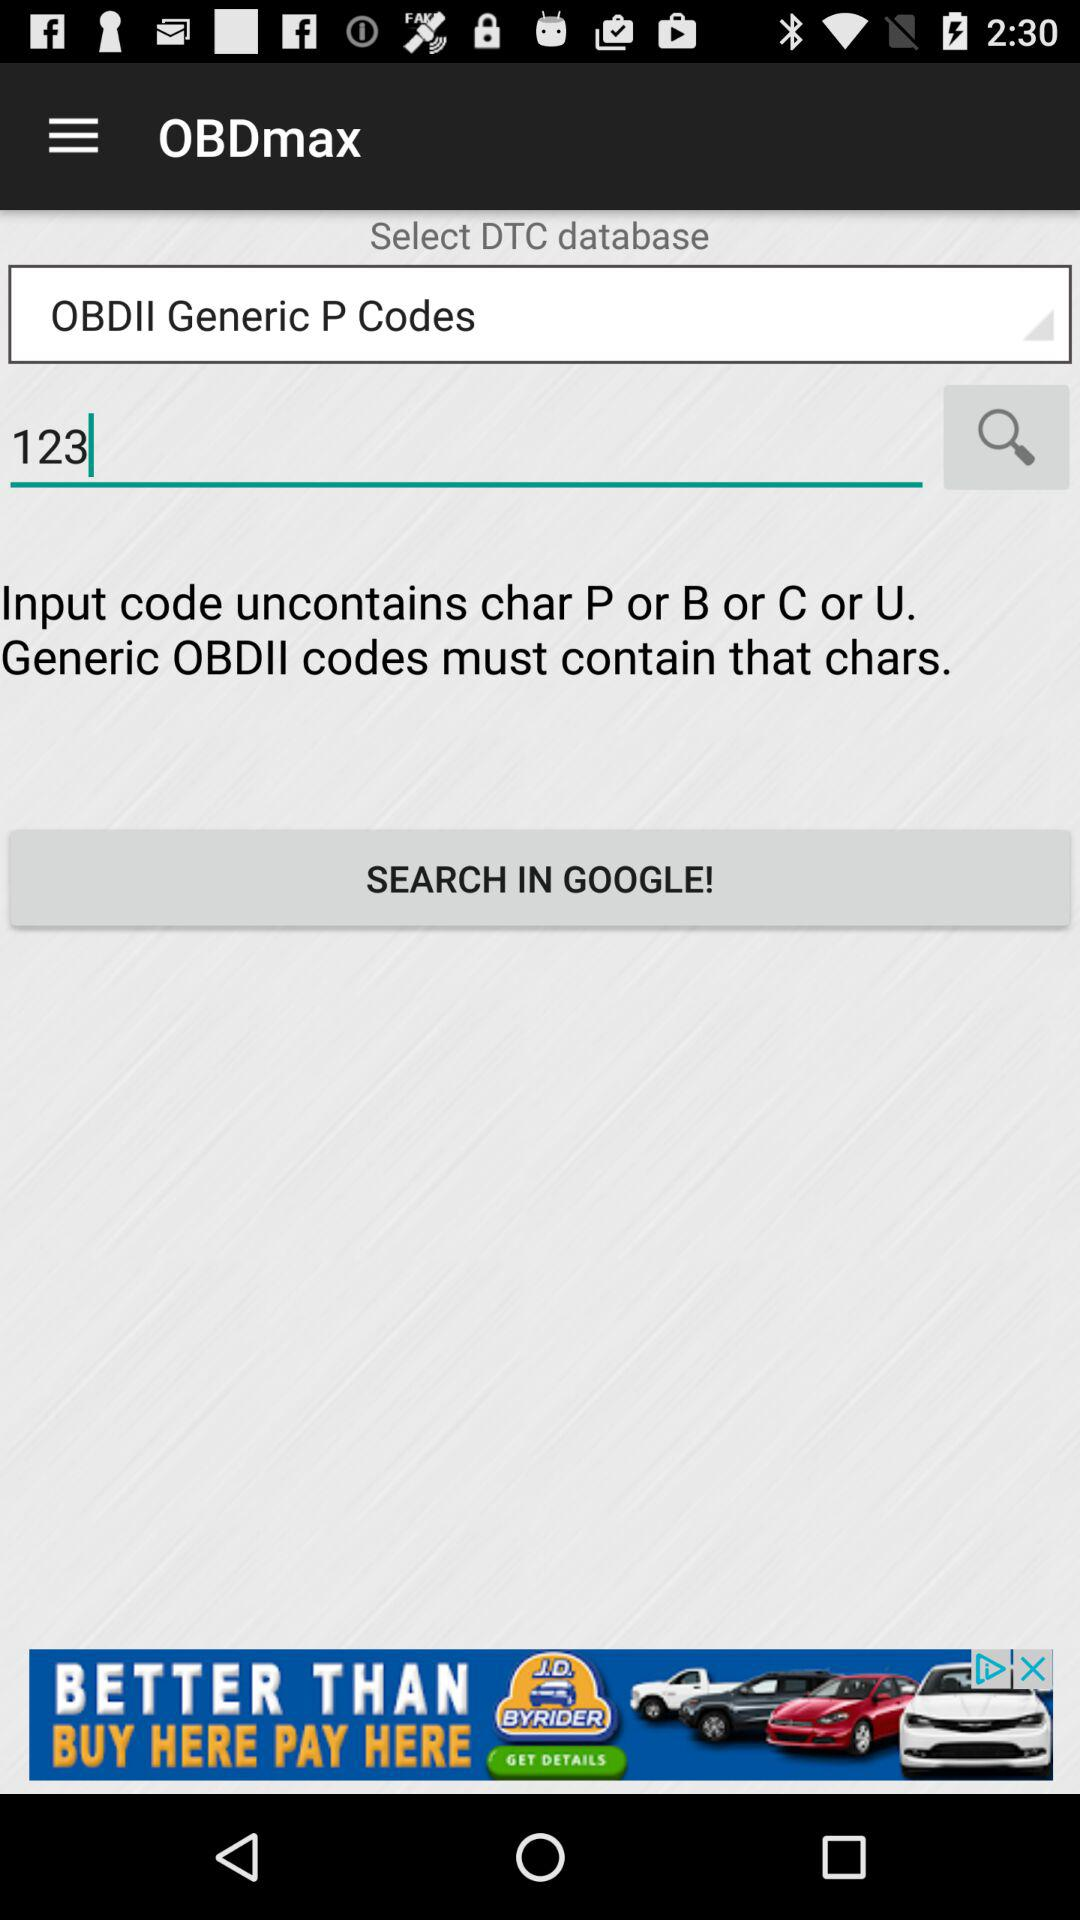Which DTC database is selected? The selected DTC database is "OBDII Generic P Codes". 